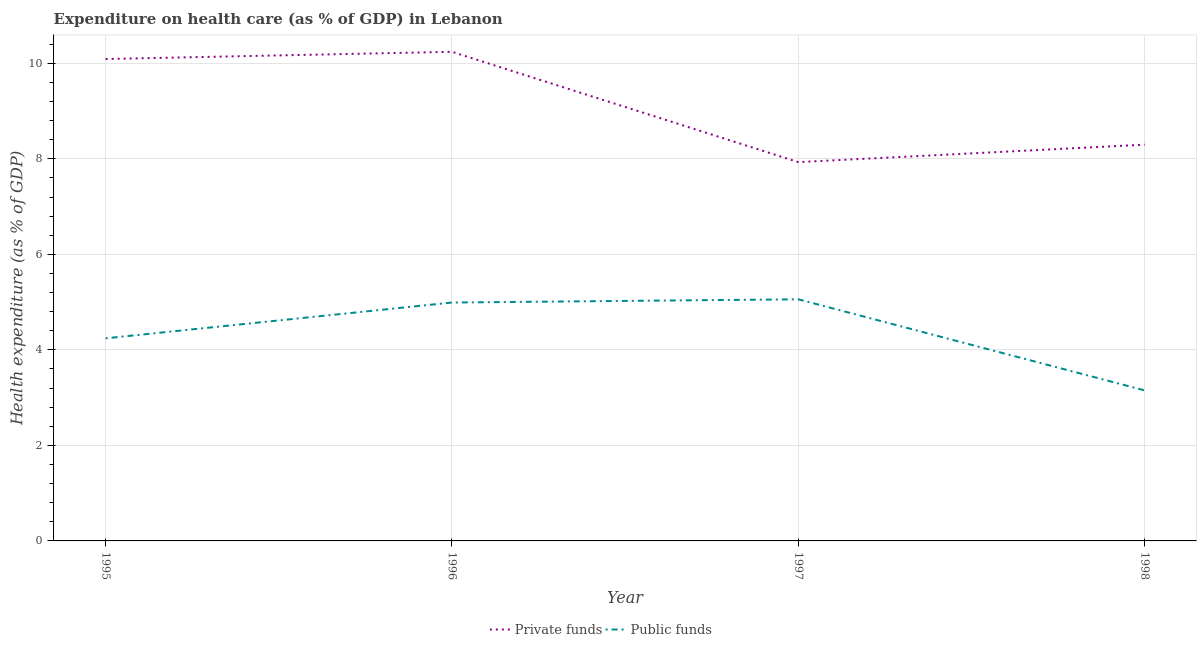Is the number of lines equal to the number of legend labels?
Offer a terse response. Yes. What is the amount of public funds spent in healthcare in 1998?
Your answer should be compact. 3.15. Across all years, what is the maximum amount of private funds spent in healthcare?
Your answer should be very brief. 10.24. Across all years, what is the minimum amount of public funds spent in healthcare?
Offer a terse response. 3.15. In which year was the amount of public funds spent in healthcare maximum?
Provide a short and direct response. 1997. What is the total amount of private funds spent in healthcare in the graph?
Keep it short and to the point. 36.56. What is the difference between the amount of private funds spent in healthcare in 1995 and that in 1996?
Offer a terse response. -0.15. What is the difference between the amount of public funds spent in healthcare in 1996 and the amount of private funds spent in healthcare in 1995?
Keep it short and to the point. -5.1. What is the average amount of private funds spent in healthcare per year?
Keep it short and to the point. 9.14. In the year 1995, what is the difference between the amount of public funds spent in healthcare and amount of private funds spent in healthcare?
Offer a very short reply. -5.85. What is the ratio of the amount of private funds spent in healthcare in 1996 to that in 1998?
Provide a short and direct response. 1.23. Is the difference between the amount of public funds spent in healthcare in 1997 and 1998 greater than the difference between the amount of private funds spent in healthcare in 1997 and 1998?
Offer a very short reply. Yes. What is the difference between the highest and the second highest amount of private funds spent in healthcare?
Your answer should be compact. 0.15. What is the difference between the highest and the lowest amount of public funds spent in healthcare?
Give a very brief answer. 1.91. Is the sum of the amount of public funds spent in healthcare in 1997 and 1998 greater than the maximum amount of private funds spent in healthcare across all years?
Offer a very short reply. No. Does the amount of public funds spent in healthcare monotonically increase over the years?
Provide a short and direct response. No. Is the amount of private funds spent in healthcare strictly greater than the amount of public funds spent in healthcare over the years?
Make the answer very short. Yes. Is the amount of private funds spent in healthcare strictly less than the amount of public funds spent in healthcare over the years?
Keep it short and to the point. No. Are the values on the major ticks of Y-axis written in scientific E-notation?
Offer a terse response. No. Does the graph contain any zero values?
Give a very brief answer. No. How many legend labels are there?
Offer a very short reply. 2. How are the legend labels stacked?
Offer a terse response. Horizontal. What is the title of the graph?
Keep it short and to the point. Expenditure on health care (as % of GDP) in Lebanon. Does "RDB concessional" appear as one of the legend labels in the graph?
Your response must be concise. No. What is the label or title of the Y-axis?
Make the answer very short. Health expenditure (as % of GDP). What is the Health expenditure (as % of GDP) in Private funds in 1995?
Your answer should be compact. 10.09. What is the Health expenditure (as % of GDP) in Public funds in 1995?
Make the answer very short. 4.24. What is the Health expenditure (as % of GDP) of Private funds in 1996?
Keep it short and to the point. 10.24. What is the Health expenditure (as % of GDP) of Public funds in 1996?
Your answer should be very brief. 4.99. What is the Health expenditure (as % of GDP) of Private funds in 1997?
Ensure brevity in your answer.  7.93. What is the Health expenditure (as % of GDP) of Public funds in 1997?
Give a very brief answer. 5.06. What is the Health expenditure (as % of GDP) in Private funds in 1998?
Offer a terse response. 8.3. What is the Health expenditure (as % of GDP) of Public funds in 1998?
Your answer should be very brief. 3.15. Across all years, what is the maximum Health expenditure (as % of GDP) of Private funds?
Offer a terse response. 10.24. Across all years, what is the maximum Health expenditure (as % of GDP) of Public funds?
Provide a short and direct response. 5.06. Across all years, what is the minimum Health expenditure (as % of GDP) in Private funds?
Provide a succinct answer. 7.93. Across all years, what is the minimum Health expenditure (as % of GDP) of Public funds?
Give a very brief answer. 3.15. What is the total Health expenditure (as % of GDP) in Private funds in the graph?
Ensure brevity in your answer.  36.56. What is the total Health expenditure (as % of GDP) of Public funds in the graph?
Keep it short and to the point. 17.45. What is the difference between the Health expenditure (as % of GDP) of Private funds in 1995 and that in 1996?
Make the answer very short. -0.15. What is the difference between the Health expenditure (as % of GDP) in Public funds in 1995 and that in 1996?
Your response must be concise. -0.75. What is the difference between the Health expenditure (as % of GDP) of Private funds in 1995 and that in 1997?
Provide a succinct answer. 2.16. What is the difference between the Health expenditure (as % of GDP) of Public funds in 1995 and that in 1997?
Offer a terse response. -0.82. What is the difference between the Health expenditure (as % of GDP) of Private funds in 1995 and that in 1998?
Make the answer very short. 1.79. What is the difference between the Health expenditure (as % of GDP) of Public funds in 1995 and that in 1998?
Provide a short and direct response. 1.09. What is the difference between the Health expenditure (as % of GDP) of Private funds in 1996 and that in 1997?
Provide a succinct answer. 2.31. What is the difference between the Health expenditure (as % of GDP) in Public funds in 1996 and that in 1997?
Your answer should be compact. -0.07. What is the difference between the Health expenditure (as % of GDP) of Private funds in 1996 and that in 1998?
Ensure brevity in your answer.  1.94. What is the difference between the Health expenditure (as % of GDP) of Public funds in 1996 and that in 1998?
Offer a terse response. 1.84. What is the difference between the Health expenditure (as % of GDP) of Private funds in 1997 and that in 1998?
Your answer should be compact. -0.37. What is the difference between the Health expenditure (as % of GDP) in Public funds in 1997 and that in 1998?
Ensure brevity in your answer.  1.91. What is the difference between the Health expenditure (as % of GDP) of Private funds in 1995 and the Health expenditure (as % of GDP) of Public funds in 1996?
Your answer should be compact. 5.1. What is the difference between the Health expenditure (as % of GDP) of Private funds in 1995 and the Health expenditure (as % of GDP) of Public funds in 1997?
Make the answer very short. 5.03. What is the difference between the Health expenditure (as % of GDP) in Private funds in 1995 and the Health expenditure (as % of GDP) in Public funds in 1998?
Give a very brief answer. 6.94. What is the difference between the Health expenditure (as % of GDP) of Private funds in 1996 and the Health expenditure (as % of GDP) of Public funds in 1997?
Provide a succinct answer. 5.18. What is the difference between the Health expenditure (as % of GDP) of Private funds in 1996 and the Health expenditure (as % of GDP) of Public funds in 1998?
Provide a short and direct response. 7.09. What is the difference between the Health expenditure (as % of GDP) of Private funds in 1997 and the Health expenditure (as % of GDP) of Public funds in 1998?
Make the answer very short. 4.78. What is the average Health expenditure (as % of GDP) in Private funds per year?
Provide a short and direct response. 9.14. What is the average Health expenditure (as % of GDP) in Public funds per year?
Your answer should be compact. 4.36. In the year 1995, what is the difference between the Health expenditure (as % of GDP) of Private funds and Health expenditure (as % of GDP) of Public funds?
Keep it short and to the point. 5.85. In the year 1996, what is the difference between the Health expenditure (as % of GDP) in Private funds and Health expenditure (as % of GDP) in Public funds?
Your answer should be compact. 5.25. In the year 1997, what is the difference between the Health expenditure (as % of GDP) in Private funds and Health expenditure (as % of GDP) in Public funds?
Offer a very short reply. 2.87. In the year 1998, what is the difference between the Health expenditure (as % of GDP) in Private funds and Health expenditure (as % of GDP) in Public funds?
Give a very brief answer. 5.14. What is the ratio of the Health expenditure (as % of GDP) of Private funds in 1995 to that in 1996?
Ensure brevity in your answer.  0.99. What is the ratio of the Health expenditure (as % of GDP) of Public funds in 1995 to that in 1996?
Your answer should be very brief. 0.85. What is the ratio of the Health expenditure (as % of GDP) in Private funds in 1995 to that in 1997?
Your answer should be compact. 1.27. What is the ratio of the Health expenditure (as % of GDP) of Public funds in 1995 to that in 1997?
Provide a short and direct response. 0.84. What is the ratio of the Health expenditure (as % of GDP) in Private funds in 1995 to that in 1998?
Your response must be concise. 1.22. What is the ratio of the Health expenditure (as % of GDP) of Public funds in 1995 to that in 1998?
Offer a very short reply. 1.35. What is the ratio of the Health expenditure (as % of GDP) in Private funds in 1996 to that in 1997?
Offer a terse response. 1.29. What is the ratio of the Health expenditure (as % of GDP) of Public funds in 1996 to that in 1997?
Your response must be concise. 0.99. What is the ratio of the Health expenditure (as % of GDP) of Private funds in 1996 to that in 1998?
Your answer should be very brief. 1.23. What is the ratio of the Health expenditure (as % of GDP) of Public funds in 1996 to that in 1998?
Make the answer very short. 1.58. What is the ratio of the Health expenditure (as % of GDP) in Private funds in 1997 to that in 1998?
Give a very brief answer. 0.96. What is the ratio of the Health expenditure (as % of GDP) in Public funds in 1997 to that in 1998?
Your answer should be very brief. 1.6. What is the difference between the highest and the second highest Health expenditure (as % of GDP) of Private funds?
Make the answer very short. 0.15. What is the difference between the highest and the second highest Health expenditure (as % of GDP) in Public funds?
Ensure brevity in your answer.  0.07. What is the difference between the highest and the lowest Health expenditure (as % of GDP) of Private funds?
Provide a succinct answer. 2.31. What is the difference between the highest and the lowest Health expenditure (as % of GDP) in Public funds?
Your answer should be compact. 1.91. 